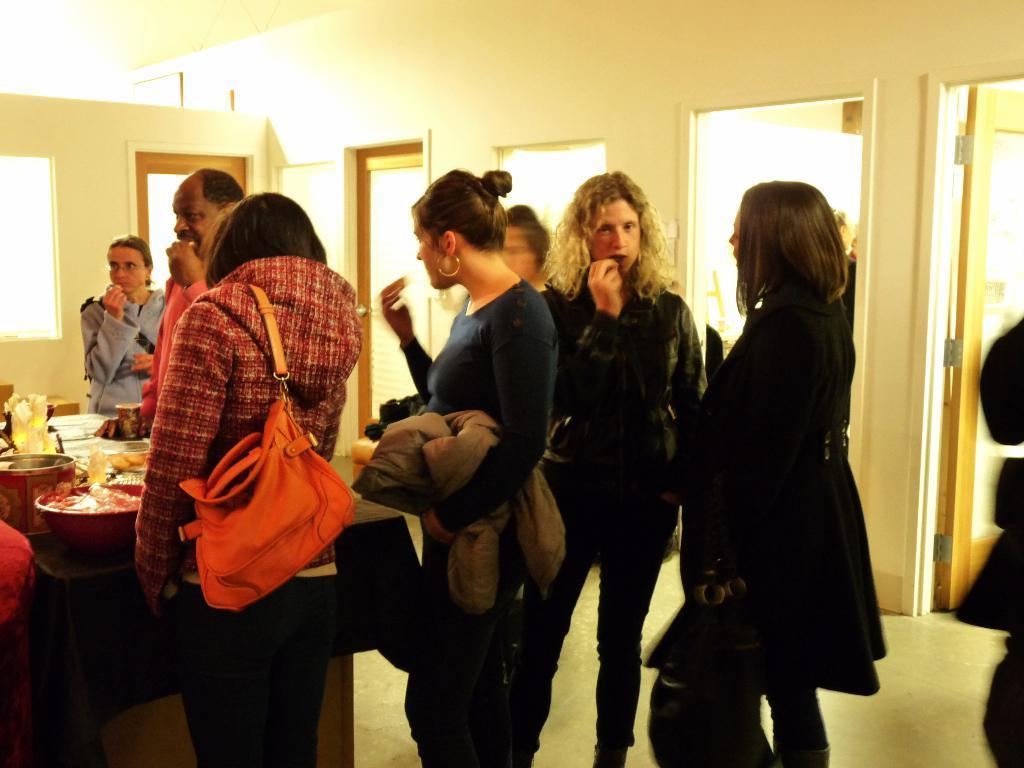Can you describe this image briefly? In this image there are a group of people standing together, in front of them there is a table served with so many food items, behind them there are door on the wall. 